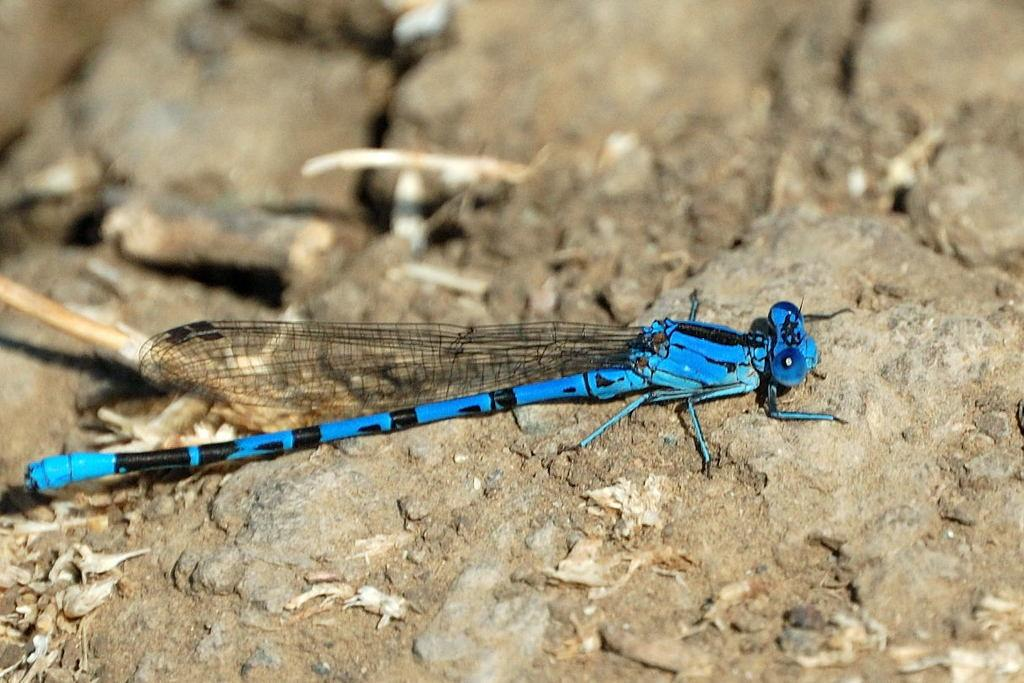What is present in the image? There is a fly in the image. Where is the fly located? The fly is on a rock land. Can you describe the rock land? The rock land has blue and black colors. What type of cloth is being used for payment in the image? There is no cloth or payment present in the image; it only features a fly on a rock land. 